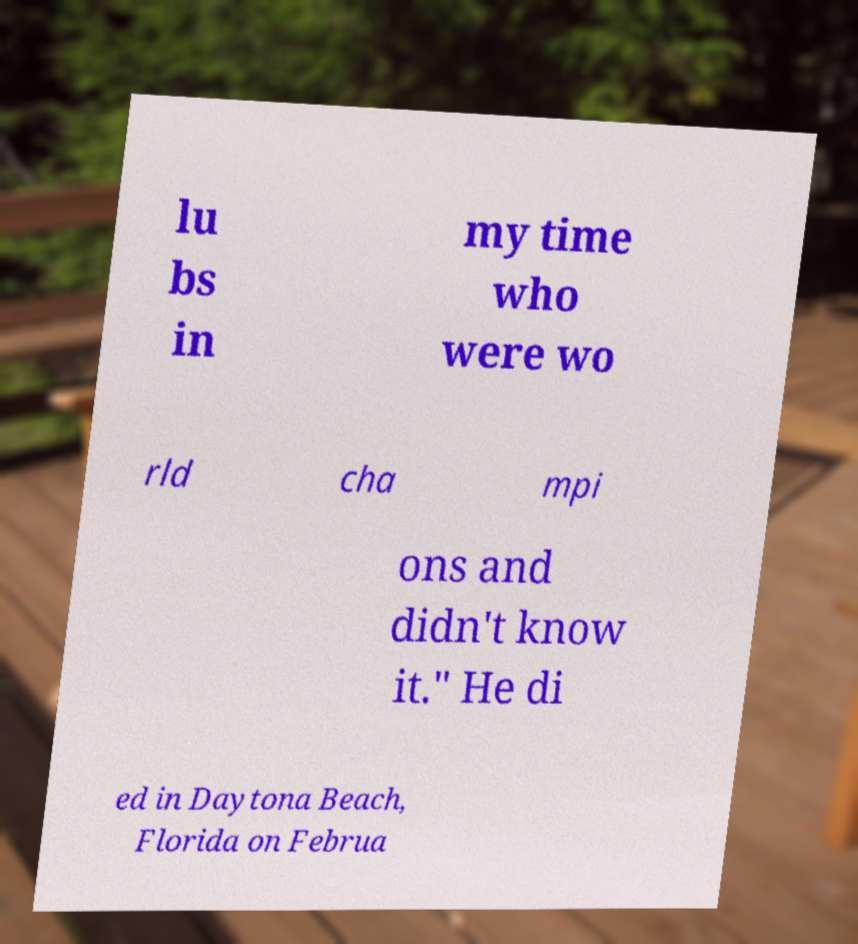For documentation purposes, I need the text within this image transcribed. Could you provide that? lu bs in my time who were wo rld cha mpi ons and didn't know it." He di ed in Daytona Beach, Florida on Februa 